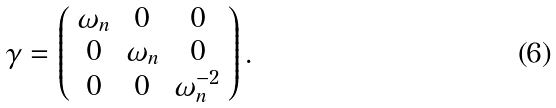Convert formula to latex. <formula><loc_0><loc_0><loc_500><loc_500>\gamma = \left ( \begin{array} { c c c } \omega _ { n } & 0 & 0 \\ 0 & \omega _ { n } & 0 \\ 0 & 0 & \omega _ { n } ^ { - 2 } \end{array} \right ) .</formula> 